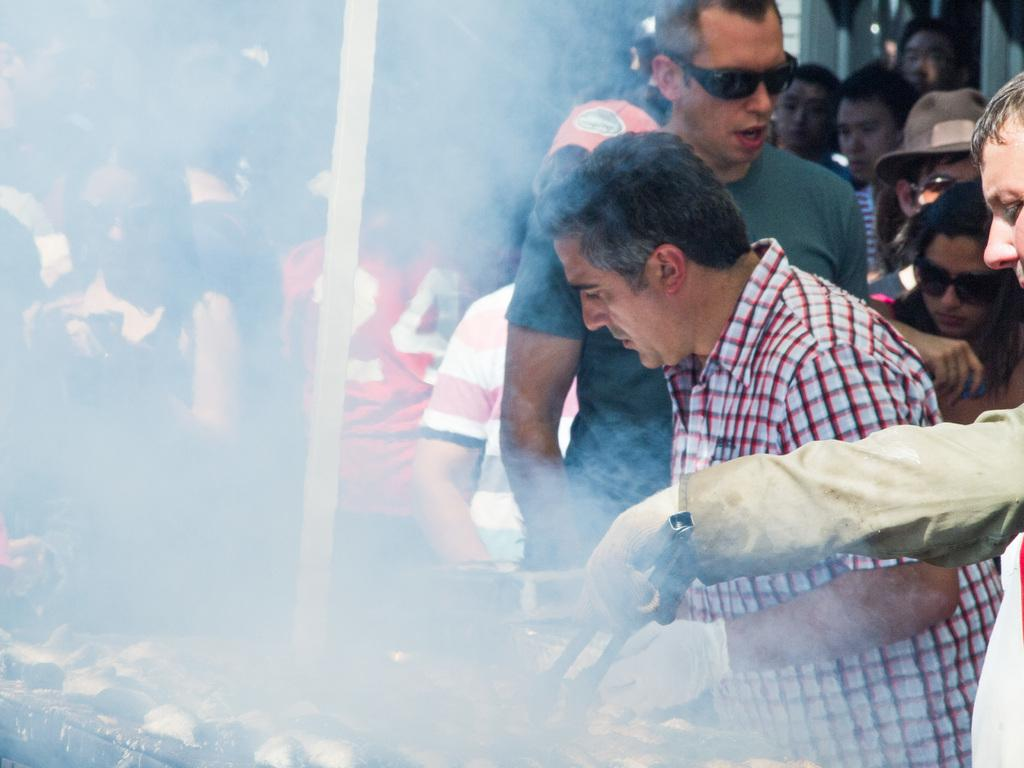What is happening on the right side of the image? There is a person on the right side of the image. What is the person doing with their tongue? The person is holding their tongue. What can be seen in front of the person? There are food items on a grill in front of the person. Are there any other people in the image? Yes, there are other people near the person. What type of toothpaste is the person using to brush their teeth in the image? There is no toothpaste or brushing activity present in the image. The person is holding their tongue, and there are food items on a grill in front of them. 